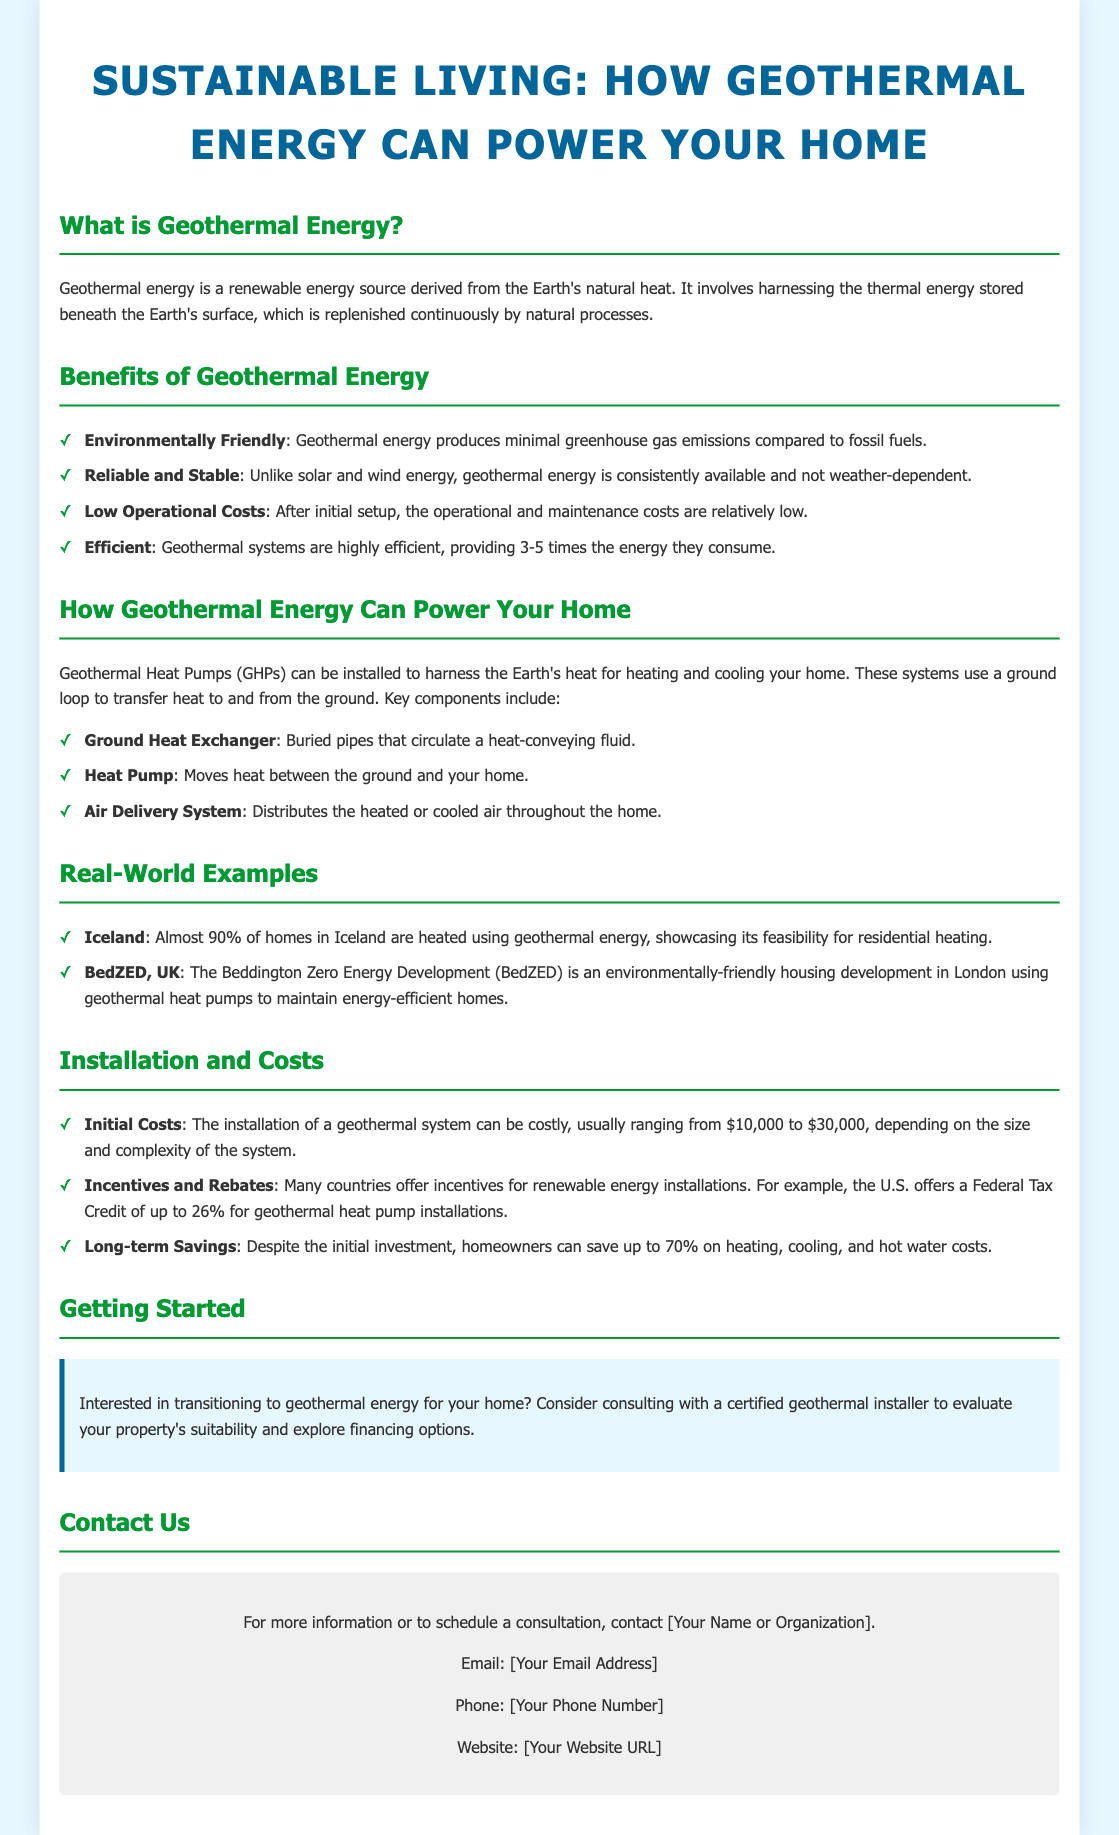What is Geothermal Energy? Geothermal energy is defined as a renewable energy source derived from the Earth's natural heat.
Answer: Renewable energy source derived from the Earth's natural heat What is the range of initial costs for installing a geothermal system? The initial costs for installation are mentioned as ranging from $10,000 to $30,000.
Answer: $10,000 to $30,000 What home in Iceland uses geothermal energy for heating? The document mentions that almost 90% of homes in Iceland are heated using geothermal energy.
Answer: Almost 90% What percentage can homeowners save on heating, cooling, and hot water costs? The document states that homeowners can save up to 70% on these costs.
Answer: 70% What type of systems is used to harness the Earth's heat for homes? The document discusses Geothermal Heat Pumps (GHPs) as systems that harness Earth's heat.
Answer: Geothermal Heat Pumps (GHPs) What offers incentives for renewable energy installations in the U.S.? The document refers to a Federal Tax Credit of up to 26% for geothermal heat pump installations.
Answer: Federal Tax Credit of up to 26% What is one key component of a geothermal energy system mentioned? The document lists "Ground Heat Exchanger" as a key component.
Answer: Ground Heat Exchanger What should someone consider before transitioning to geothermal energy? Interested individuals are advised to consult with a certified geothermal installer.
Answer: Consult with a certified geothermal installer 